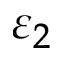<formula> <loc_0><loc_0><loc_500><loc_500>\varepsilon _ { 2 }</formula> 